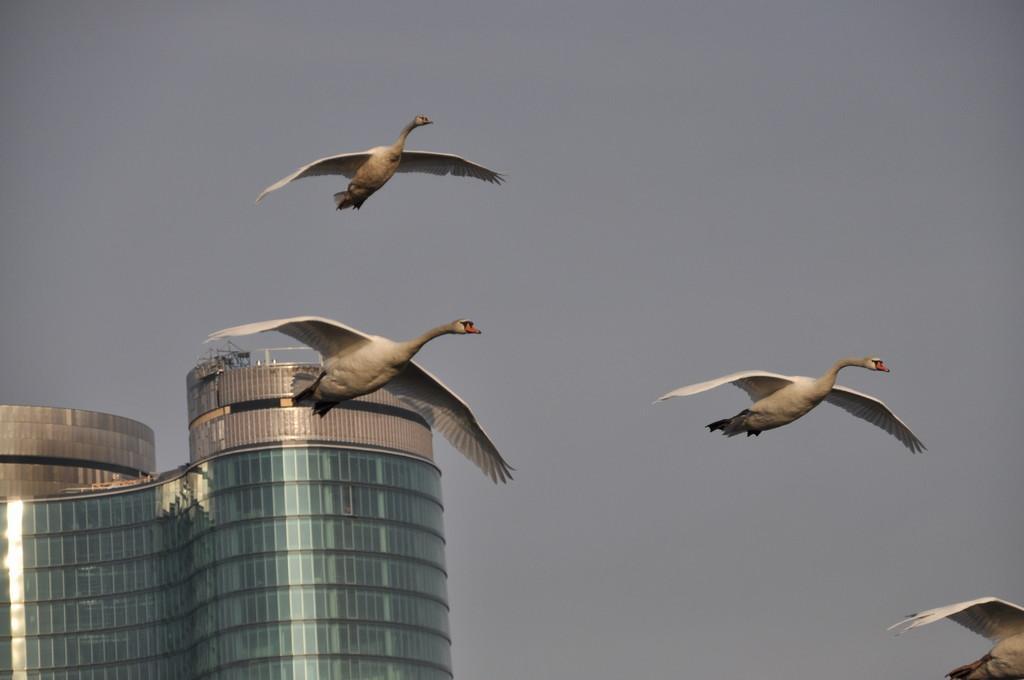Describe this image in one or two sentences. In this picture, there are birds flying on the sky towards the right. At the bottom left, there is a building. In the background, there is a sky. 